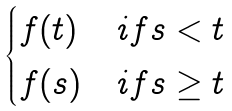Convert formula to latex. <formula><loc_0><loc_0><loc_500><loc_500>\begin{cases} f ( t ) & i f s < t \\ f ( s ) & i f s \geq t \end{cases}</formula> 